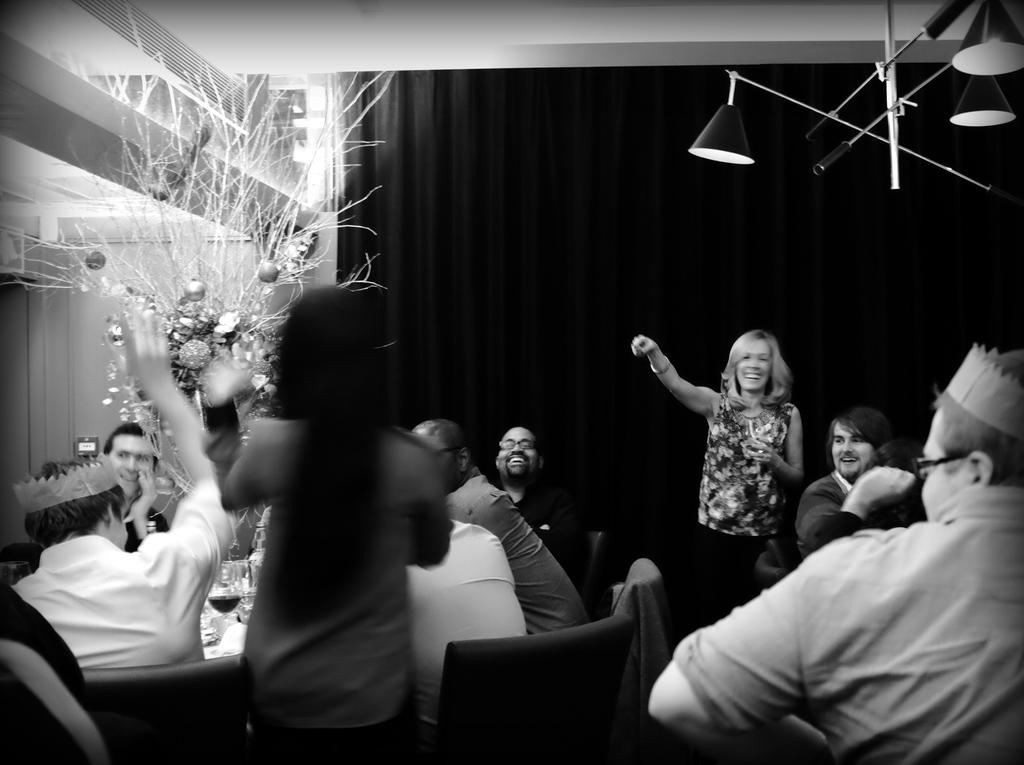How many people are in the room? There are people in the room, but the exact number is not specified. What are some of the people in the room doing? Some people are sitting on chairs, and two ladies are standing. What can be seen on the roof of the room? There are lights attached to the roof. What is located at the back of the room? There is a decorative item at the back of the room. Can you see any planes flying in the room? No, there are no planes visible in the room. Is there a hen present in the room? No, there is no mention of a hen in the room. 